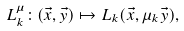Convert formula to latex. <formula><loc_0><loc_0><loc_500><loc_500>L _ { k } ^ { \mu } \colon ( \vec { x } , \vec { y } ) \mapsto L _ { k } ( \vec { x } , \mu _ { k } \vec { y } ) ,</formula> 